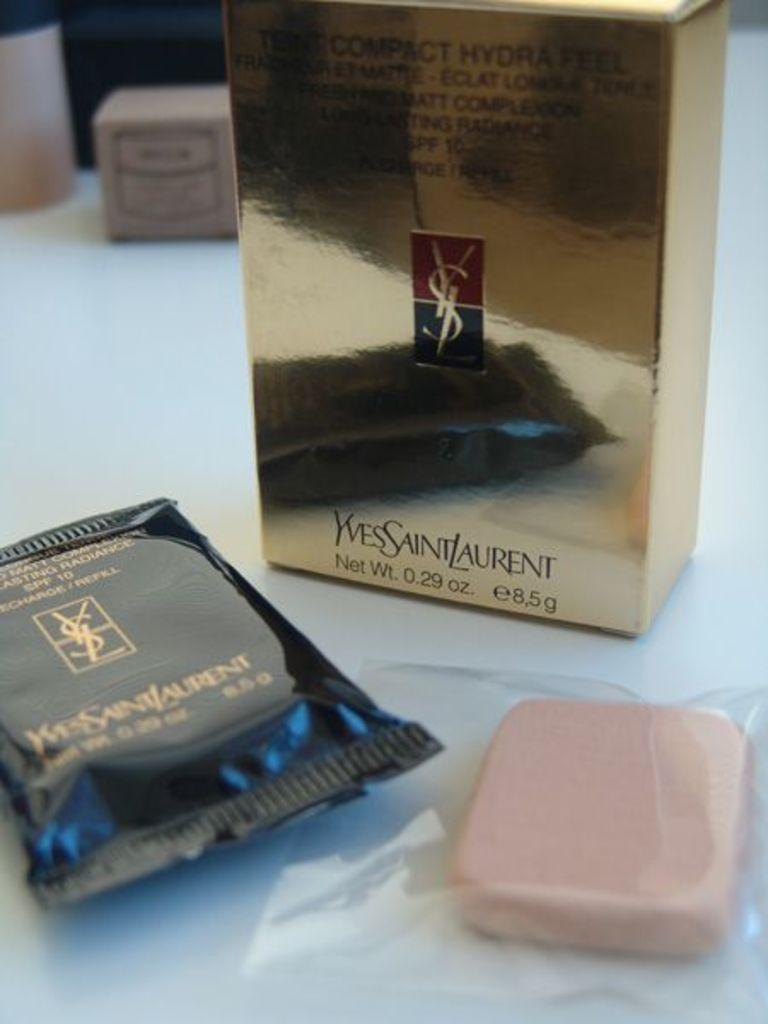<image>
Present a compact description of the photo's key features. A bar of soap next to a black bag and a box from Yves Saint Laurent. 